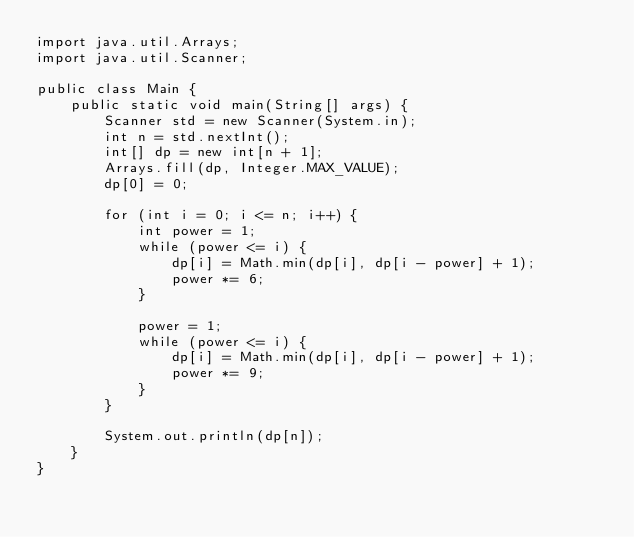<code> <loc_0><loc_0><loc_500><loc_500><_Java_>import java.util.Arrays;
import java.util.Scanner;

public class Main {
    public static void main(String[] args) {
        Scanner std = new Scanner(System.in);
        int n = std.nextInt();
        int[] dp = new int[n + 1];
        Arrays.fill(dp, Integer.MAX_VALUE);
        dp[0] = 0;

        for (int i = 0; i <= n; i++) {
            int power = 1;
            while (power <= i) {
                dp[i] = Math.min(dp[i], dp[i - power] + 1);
                power *= 6;
            }

            power = 1;
            while (power <= i) {
                dp[i] = Math.min(dp[i], dp[i - power] + 1);
                power *= 9;
            }
        }

        System.out.println(dp[n]);
    }
}
</code> 